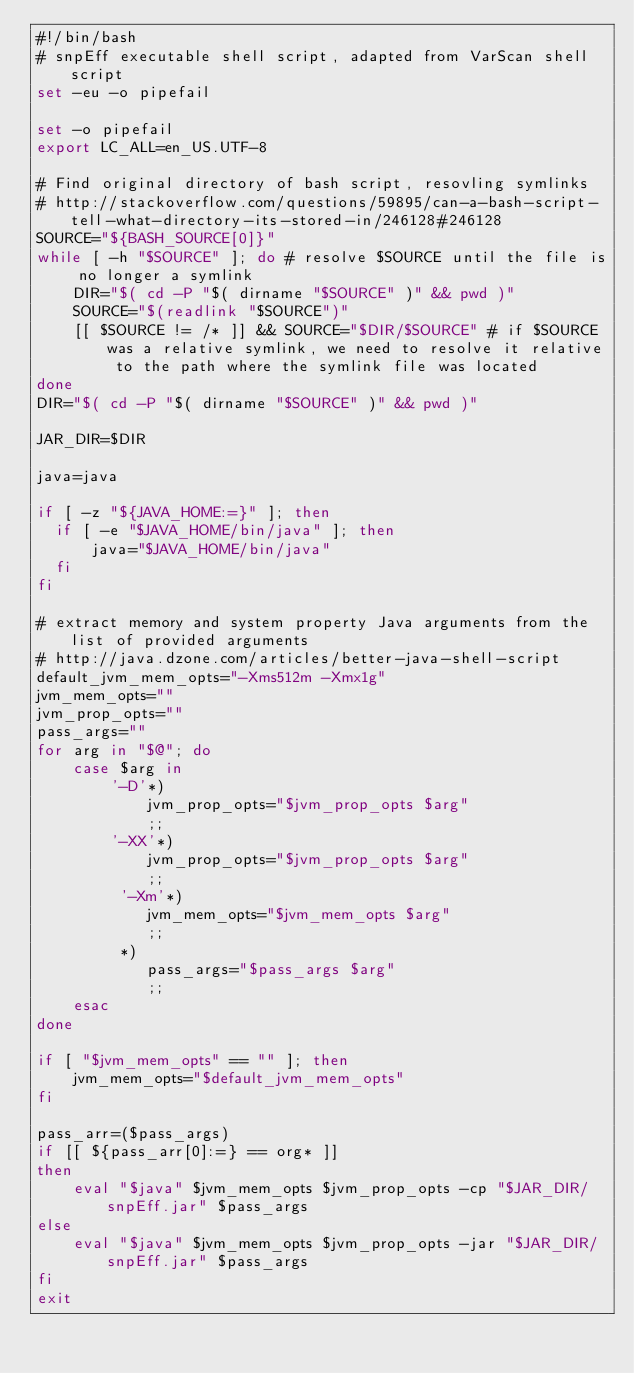<code> <loc_0><loc_0><loc_500><loc_500><_Bash_>#!/bin/bash
# snpEff executable shell script, adapted from VarScan shell script
set -eu -o pipefail

set -o pipefail
export LC_ALL=en_US.UTF-8

# Find original directory of bash script, resovling symlinks
# http://stackoverflow.com/questions/59895/can-a-bash-script-tell-what-directory-its-stored-in/246128#246128
SOURCE="${BASH_SOURCE[0]}"
while [ -h "$SOURCE" ]; do # resolve $SOURCE until the file is no longer a symlink
    DIR="$( cd -P "$( dirname "$SOURCE" )" && pwd )"
    SOURCE="$(readlink "$SOURCE")"
    [[ $SOURCE != /* ]] && SOURCE="$DIR/$SOURCE" # if $SOURCE was a relative symlink, we need to resolve it relative to the path where the symlink file was located
done
DIR="$( cd -P "$( dirname "$SOURCE" )" && pwd )"

JAR_DIR=$DIR

java=java

if [ -z "${JAVA_HOME:=}" ]; then
  if [ -e "$JAVA_HOME/bin/java" ]; then
      java="$JAVA_HOME/bin/java"
  fi
fi

# extract memory and system property Java arguments from the list of provided arguments
# http://java.dzone.com/articles/better-java-shell-script
default_jvm_mem_opts="-Xms512m -Xmx1g"
jvm_mem_opts=""
jvm_prop_opts=""
pass_args=""
for arg in "$@"; do
    case $arg in
        '-D'*)
            jvm_prop_opts="$jvm_prop_opts $arg"
            ;;
        '-XX'*)
            jvm_prop_opts="$jvm_prop_opts $arg"
            ;;
         '-Xm'*)
            jvm_mem_opts="$jvm_mem_opts $arg"
            ;;
         *)
            pass_args="$pass_args $arg"
            ;;
    esac
done

if [ "$jvm_mem_opts" == "" ]; then
    jvm_mem_opts="$default_jvm_mem_opts"
fi

pass_arr=($pass_args)
if [[ ${pass_arr[0]:=} == org* ]]
then
    eval "$java" $jvm_mem_opts $jvm_prop_opts -cp "$JAR_DIR/snpEff.jar" $pass_args
else
    eval "$java" $jvm_mem_opts $jvm_prop_opts -jar "$JAR_DIR/snpEff.jar" $pass_args
fi
exit
</code> 